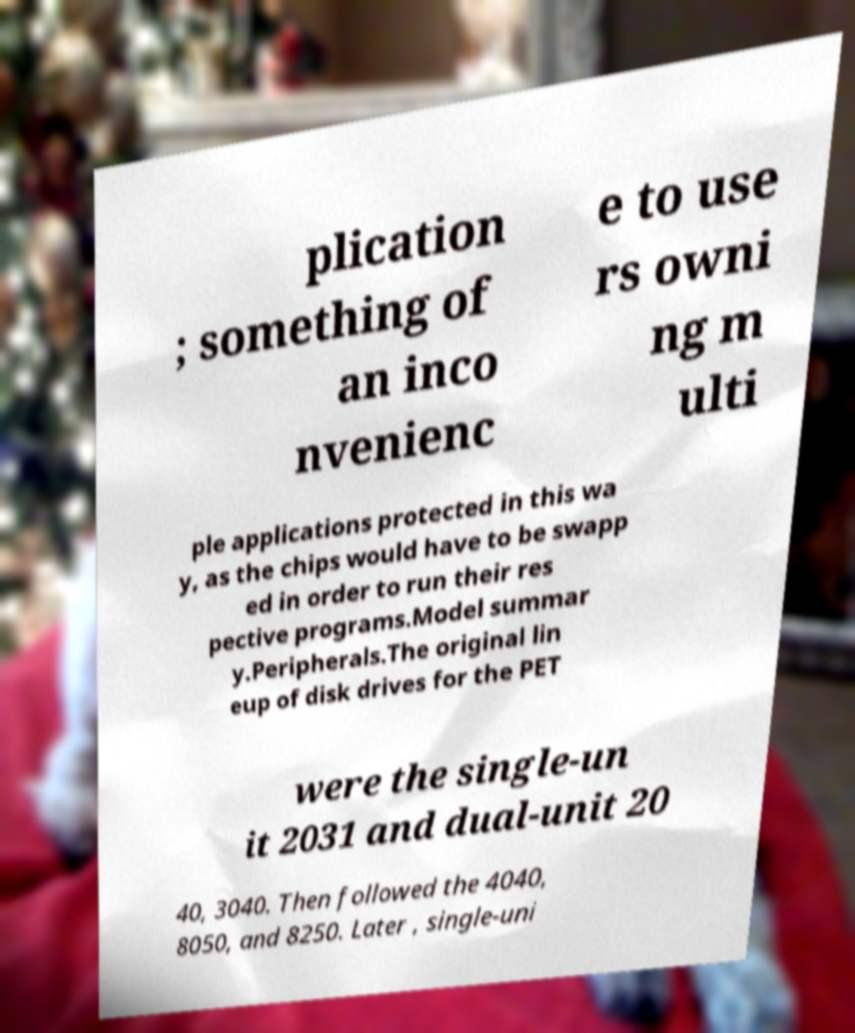There's text embedded in this image that I need extracted. Can you transcribe it verbatim? plication ; something of an inco nvenienc e to use rs owni ng m ulti ple applications protected in this wa y, as the chips would have to be swapp ed in order to run their res pective programs.Model summar y.Peripherals.The original lin eup of disk drives for the PET were the single-un it 2031 and dual-unit 20 40, 3040. Then followed the 4040, 8050, and 8250. Later , single-uni 